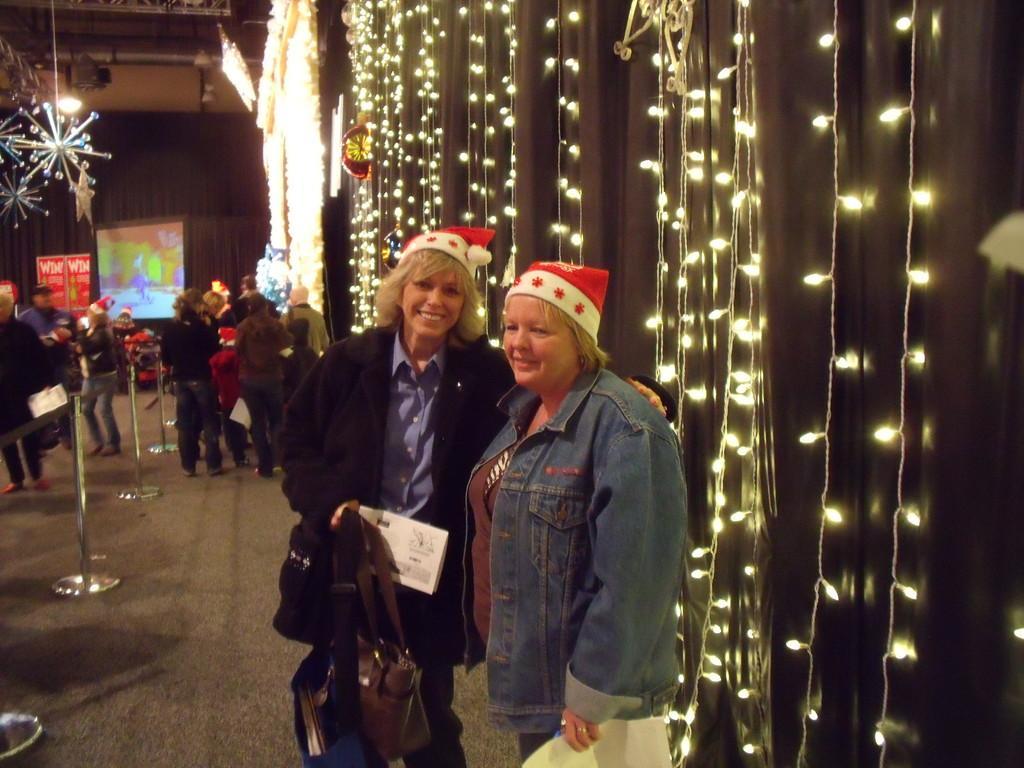Can you describe this image briefly? In this image in front there are two persons wearing a smile on their faces. Behind them there are curtains and lights. On the backside there are a few people standing on the floor. Beside them there are roads. Behind them there is a TV. On the backside there is a wall and at the top of the roof there is a wall. 